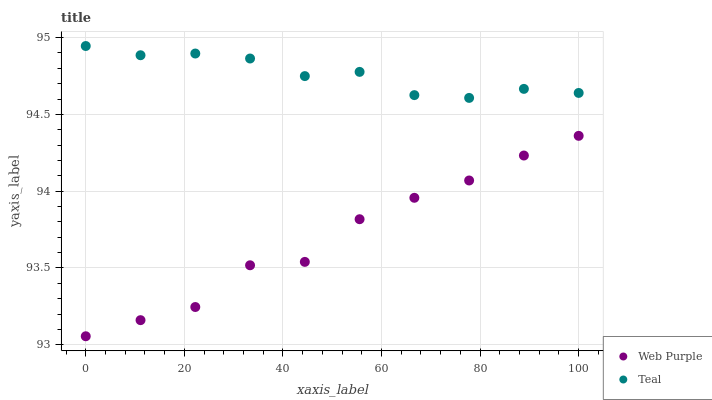Does Web Purple have the minimum area under the curve?
Answer yes or no. Yes. Does Teal have the maximum area under the curve?
Answer yes or no. Yes. Does Teal have the minimum area under the curve?
Answer yes or no. No. Is Teal the smoothest?
Answer yes or no. Yes. Is Web Purple the roughest?
Answer yes or no. Yes. Is Teal the roughest?
Answer yes or no. No. Does Web Purple have the lowest value?
Answer yes or no. Yes. Does Teal have the lowest value?
Answer yes or no. No. Does Teal have the highest value?
Answer yes or no. Yes. Is Web Purple less than Teal?
Answer yes or no. Yes. Is Teal greater than Web Purple?
Answer yes or no. Yes. Does Web Purple intersect Teal?
Answer yes or no. No. 